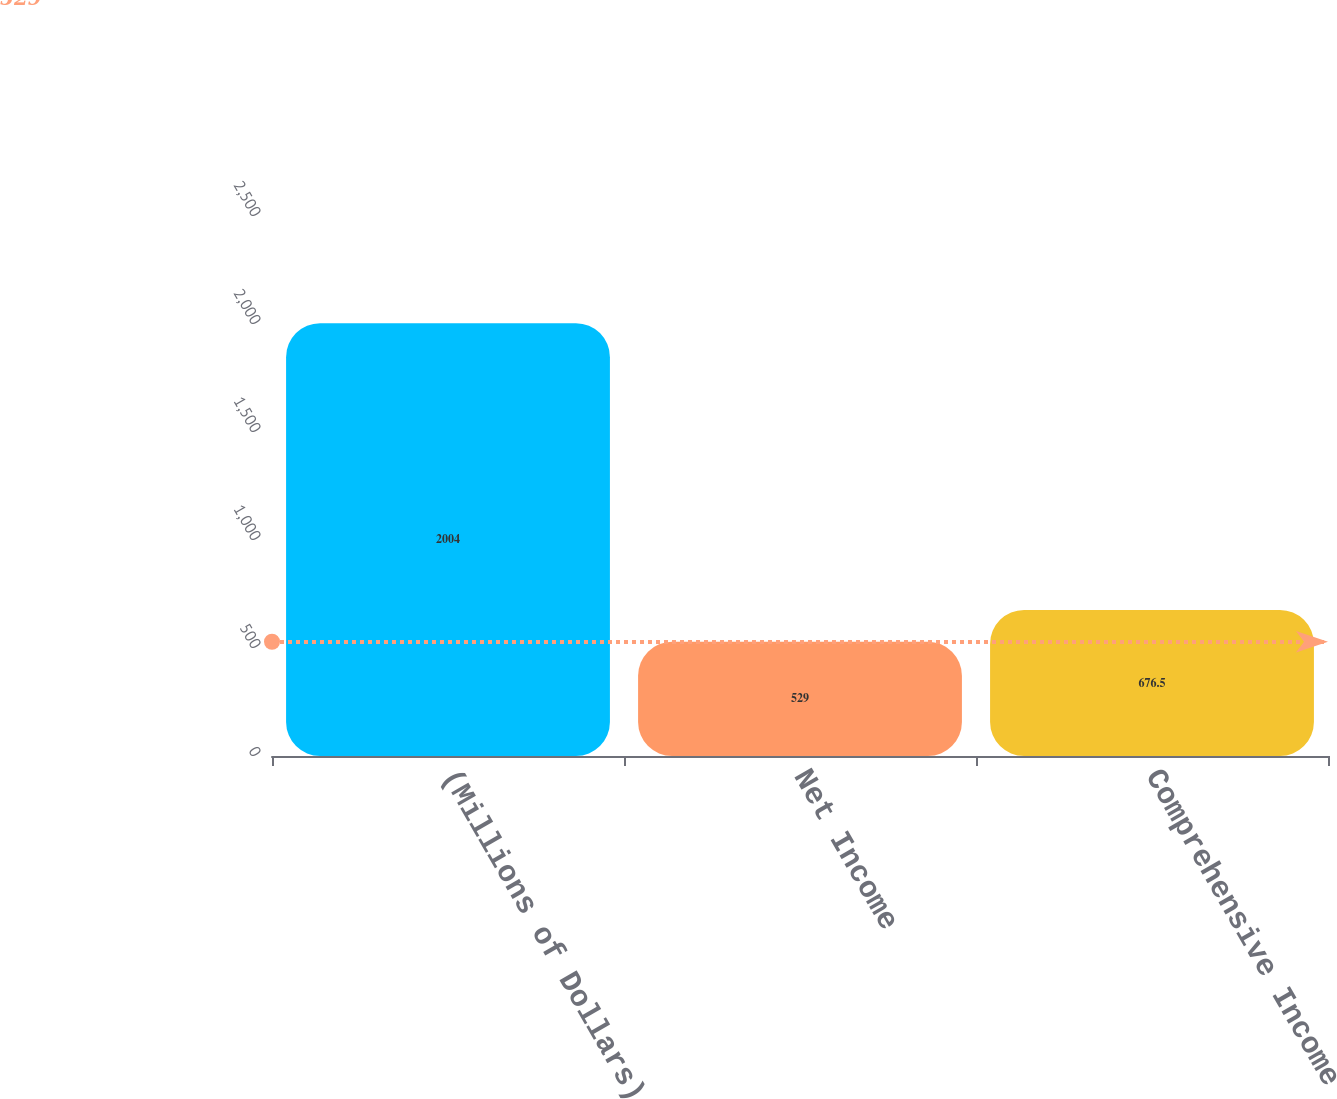<chart> <loc_0><loc_0><loc_500><loc_500><bar_chart><fcel>(Millions of Dollars)<fcel>Net Income<fcel>Comprehensive Income<nl><fcel>2004<fcel>529<fcel>676.5<nl></chart> 